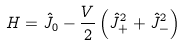<formula> <loc_0><loc_0><loc_500><loc_500>H = \hat { J } _ { 0 } - \frac { V } { 2 } \left ( \hat { J } _ { + } ^ { 2 } + \hat { J } _ { - } ^ { 2 } \right )</formula> 